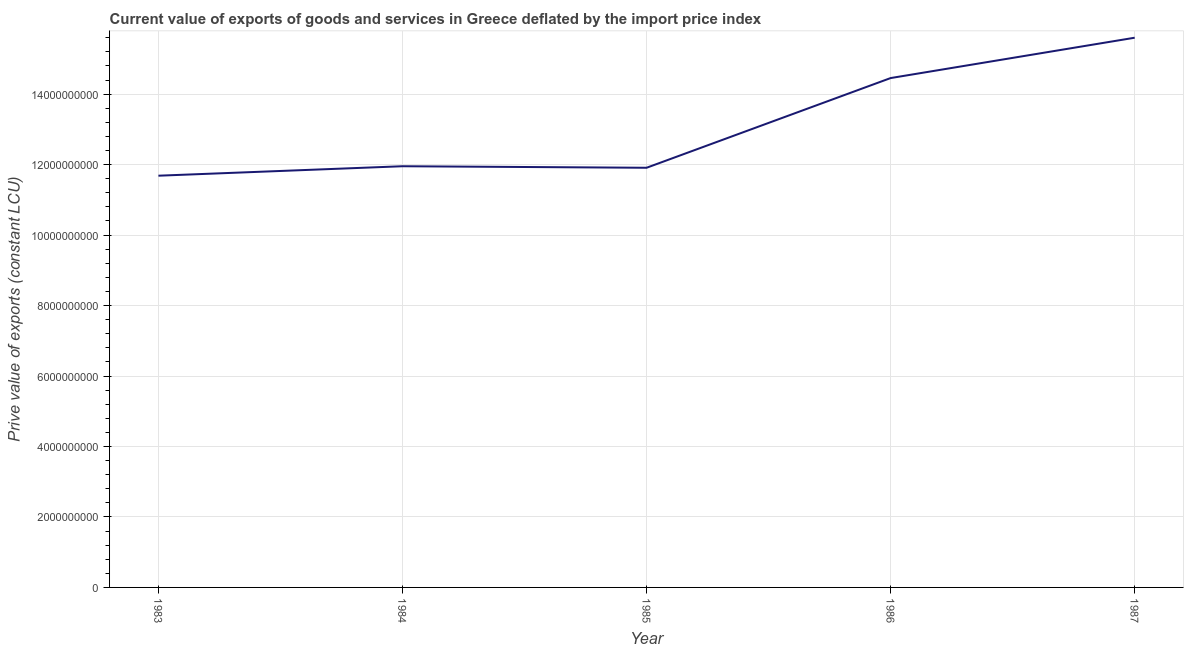What is the price value of exports in 1983?
Your answer should be very brief. 1.17e+1. Across all years, what is the maximum price value of exports?
Provide a succinct answer. 1.56e+1. Across all years, what is the minimum price value of exports?
Give a very brief answer. 1.17e+1. In which year was the price value of exports minimum?
Keep it short and to the point. 1983. What is the sum of the price value of exports?
Provide a short and direct response. 6.56e+1. What is the difference between the price value of exports in 1984 and 1986?
Ensure brevity in your answer.  -2.50e+09. What is the average price value of exports per year?
Offer a terse response. 1.31e+1. What is the median price value of exports?
Provide a succinct answer. 1.20e+1. In how many years, is the price value of exports greater than 1600000000 LCU?
Your response must be concise. 5. What is the ratio of the price value of exports in 1983 to that in 1986?
Give a very brief answer. 0.81. Is the price value of exports in 1983 less than that in 1985?
Keep it short and to the point. Yes. What is the difference between the highest and the second highest price value of exports?
Give a very brief answer. 1.14e+09. What is the difference between the highest and the lowest price value of exports?
Keep it short and to the point. 3.92e+09. Are the values on the major ticks of Y-axis written in scientific E-notation?
Provide a succinct answer. No. What is the title of the graph?
Your answer should be very brief. Current value of exports of goods and services in Greece deflated by the import price index. What is the label or title of the X-axis?
Offer a terse response. Year. What is the label or title of the Y-axis?
Your response must be concise. Prive value of exports (constant LCU). What is the Prive value of exports (constant LCU) of 1983?
Keep it short and to the point. 1.17e+1. What is the Prive value of exports (constant LCU) of 1984?
Offer a very short reply. 1.20e+1. What is the Prive value of exports (constant LCU) in 1985?
Provide a succinct answer. 1.19e+1. What is the Prive value of exports (constant LCU) in 1986?
Give a very brief answer. 1.45e+1. What is the Prive value of exports (constant LCU) in 1987?
Your answer should be compact. 1.56e+1. What is the difference between the Prive value of exports (constant LCU) in 1983 and 1984?
Your response must be concise. -2.69e+08. What is the difference between the Prive value of exports (constant LCU) in 1983 and 1985?
Your response must be concise. -2.25e+08. What is the difference between the Prive value of exports (constant LCU) in 1983 and 1986?
Offer a terse response. -2.77e+09. What is the difference between the Prive value of exports (constant LCU) in 1983 and 1987?
Provide a short and direct response. -3.92e+09. What is the difference between the Prive value of exports (constant LCU) in 1984 and 1985?
Provide a short and direct response. 4.35e+07. What is the difference between the Prive value of exports (constant LCU) in 1984 and 1986?
Make the answer very short. -2.50e+09. What is the difference between the Prive value of exports (constant LCU) in 1984 and 1987?
Give a very brief answer. -3.65e+09. What is the difference between the Prive value of exports (constant LCU) in 1985 and 1986?
Ensure brevity in your answer.  -2.55e+09. What is the difference between the Prive value of exports (constant LCU) in 1985 and 1987?
Your answer should be very brief. -3.69e+09. What is the difference between the Prive value of exports (constant LCU) in 1986 and 1987?
Give a very brief answer. -1.14e+09. What is the ratio of the Prive value of exports (constant LCU) in 1983 to that in 1984?
Give a very brief answer. 0.98. What is the ratio of the Prive value of exports (constant LCU) in 1983 to that in 1986?
Offer a terse response. 0.81. What is the ratio of the Prive value of exports (constant LCU) in 1983 to that in 1987?
Provide a succinct answer. 0.75. What is the ratio of the Prive value of exports (constant LCU) in 1984 to that in 1985?
Offer a very short reply. 1. What is the ratio of the Prive value of exports (constant LCU) in 1984 to that in 1986?
Ensure brevity in your answer.  0.83. What is the ratio of the Prive value of exports (constant LCU) in 1984 to that in 1987?
Give a very brief answer. 0.77. What is the ratio of the Prive value of exports (constant LCU) in 1985 to that in 1986?
Ensure brevity in your answer.  0.82. What is the ratio of the Prive value of exports (constant LCU) in 1985 to that in 1987?
Give a very brief answer. 0.76. What is the ratio of the Prive value of exports (constant LCU) in 1986 to that in 1987?
Offer a very short reply. 0.93. 